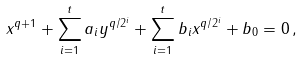Convert formula to latex. <formula><loc_0><loc_0><loc_500><loc_500>x ^ { q + 1 } + \sum _ { i = 1 } ^ { t } a _ { i } y ^ { q / 2 ^ { i } } + \sum _ { i = 1 } ^ { t } b _ { i } x ^ { q / 2 ^ { i } } + b _ { 0 } = 0 \, ,</formula> 